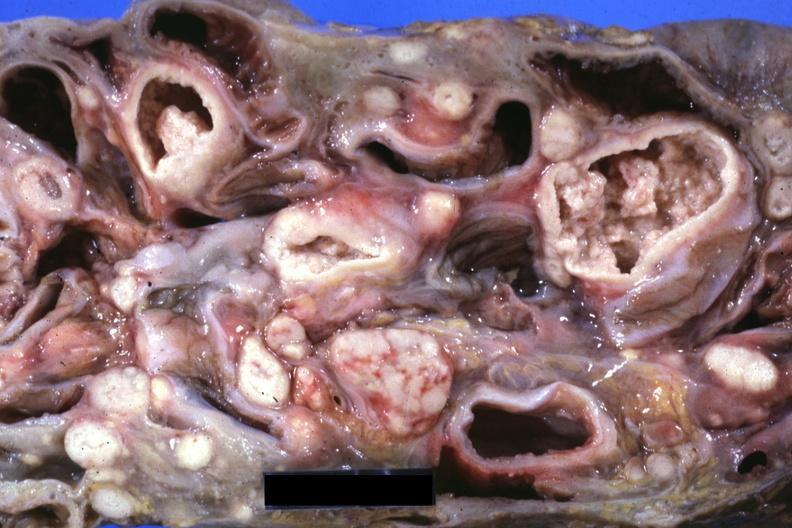s mass of intestines and mesenteric nodes showing lesions that look more like carcinoma but are in fact tuberculosis?
Answer the question using a single word or phrase. Yes 